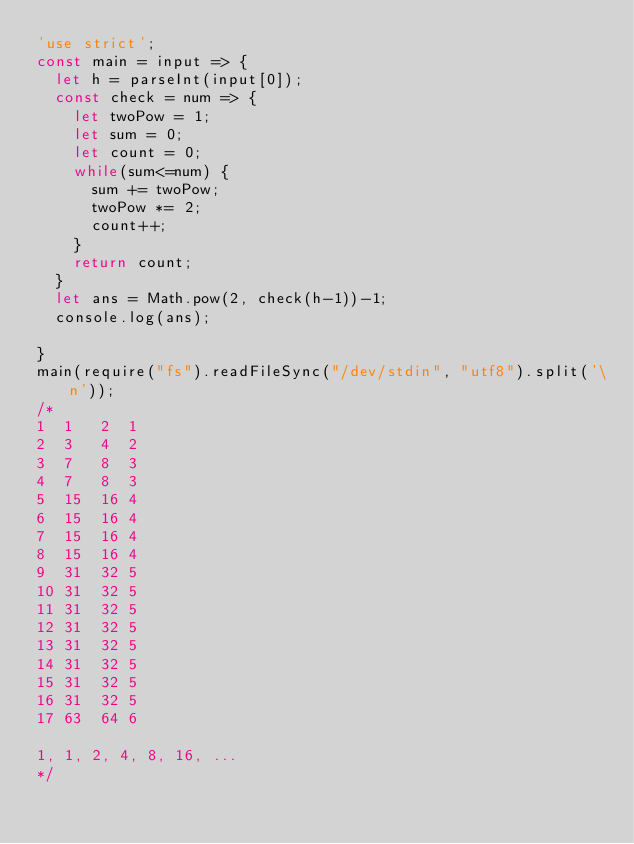<code> <loc_0><loc_0><loc_500><loc_500><_JavaScript_>'use strict';
const main = input => {
  let h = parseInt(input[0]);
  const check = num => {
    let twoPow = 1;
    let sum = 0;
    let count = 0;
    while(sum<=num) {
      sum += twoPow;
      twoPow *= 2;
      count++;
    }
    return count;
  }
  let ans = Math.pow(2, check(h-1))-1;
  console.log(ans);
  
}
main(require("fs").readFileSync("/dev/stdin", "utf8").split('\n'));
/*
1  1   2  1
2  3   4  2
3  7   8  3
4  7   8  3
5  15  16 4
6  15  16 4
7  15  16 4
8  15  16 4
9  31  32 5
10 31  32 5
11 31  32 5
12 31  32 5
13 31  32 5
14 31  32 5
15 31  32 5
16 31  32 5
17 63  64 6

1, 1, 2, 4, 8, 16, ...
*/</code> 